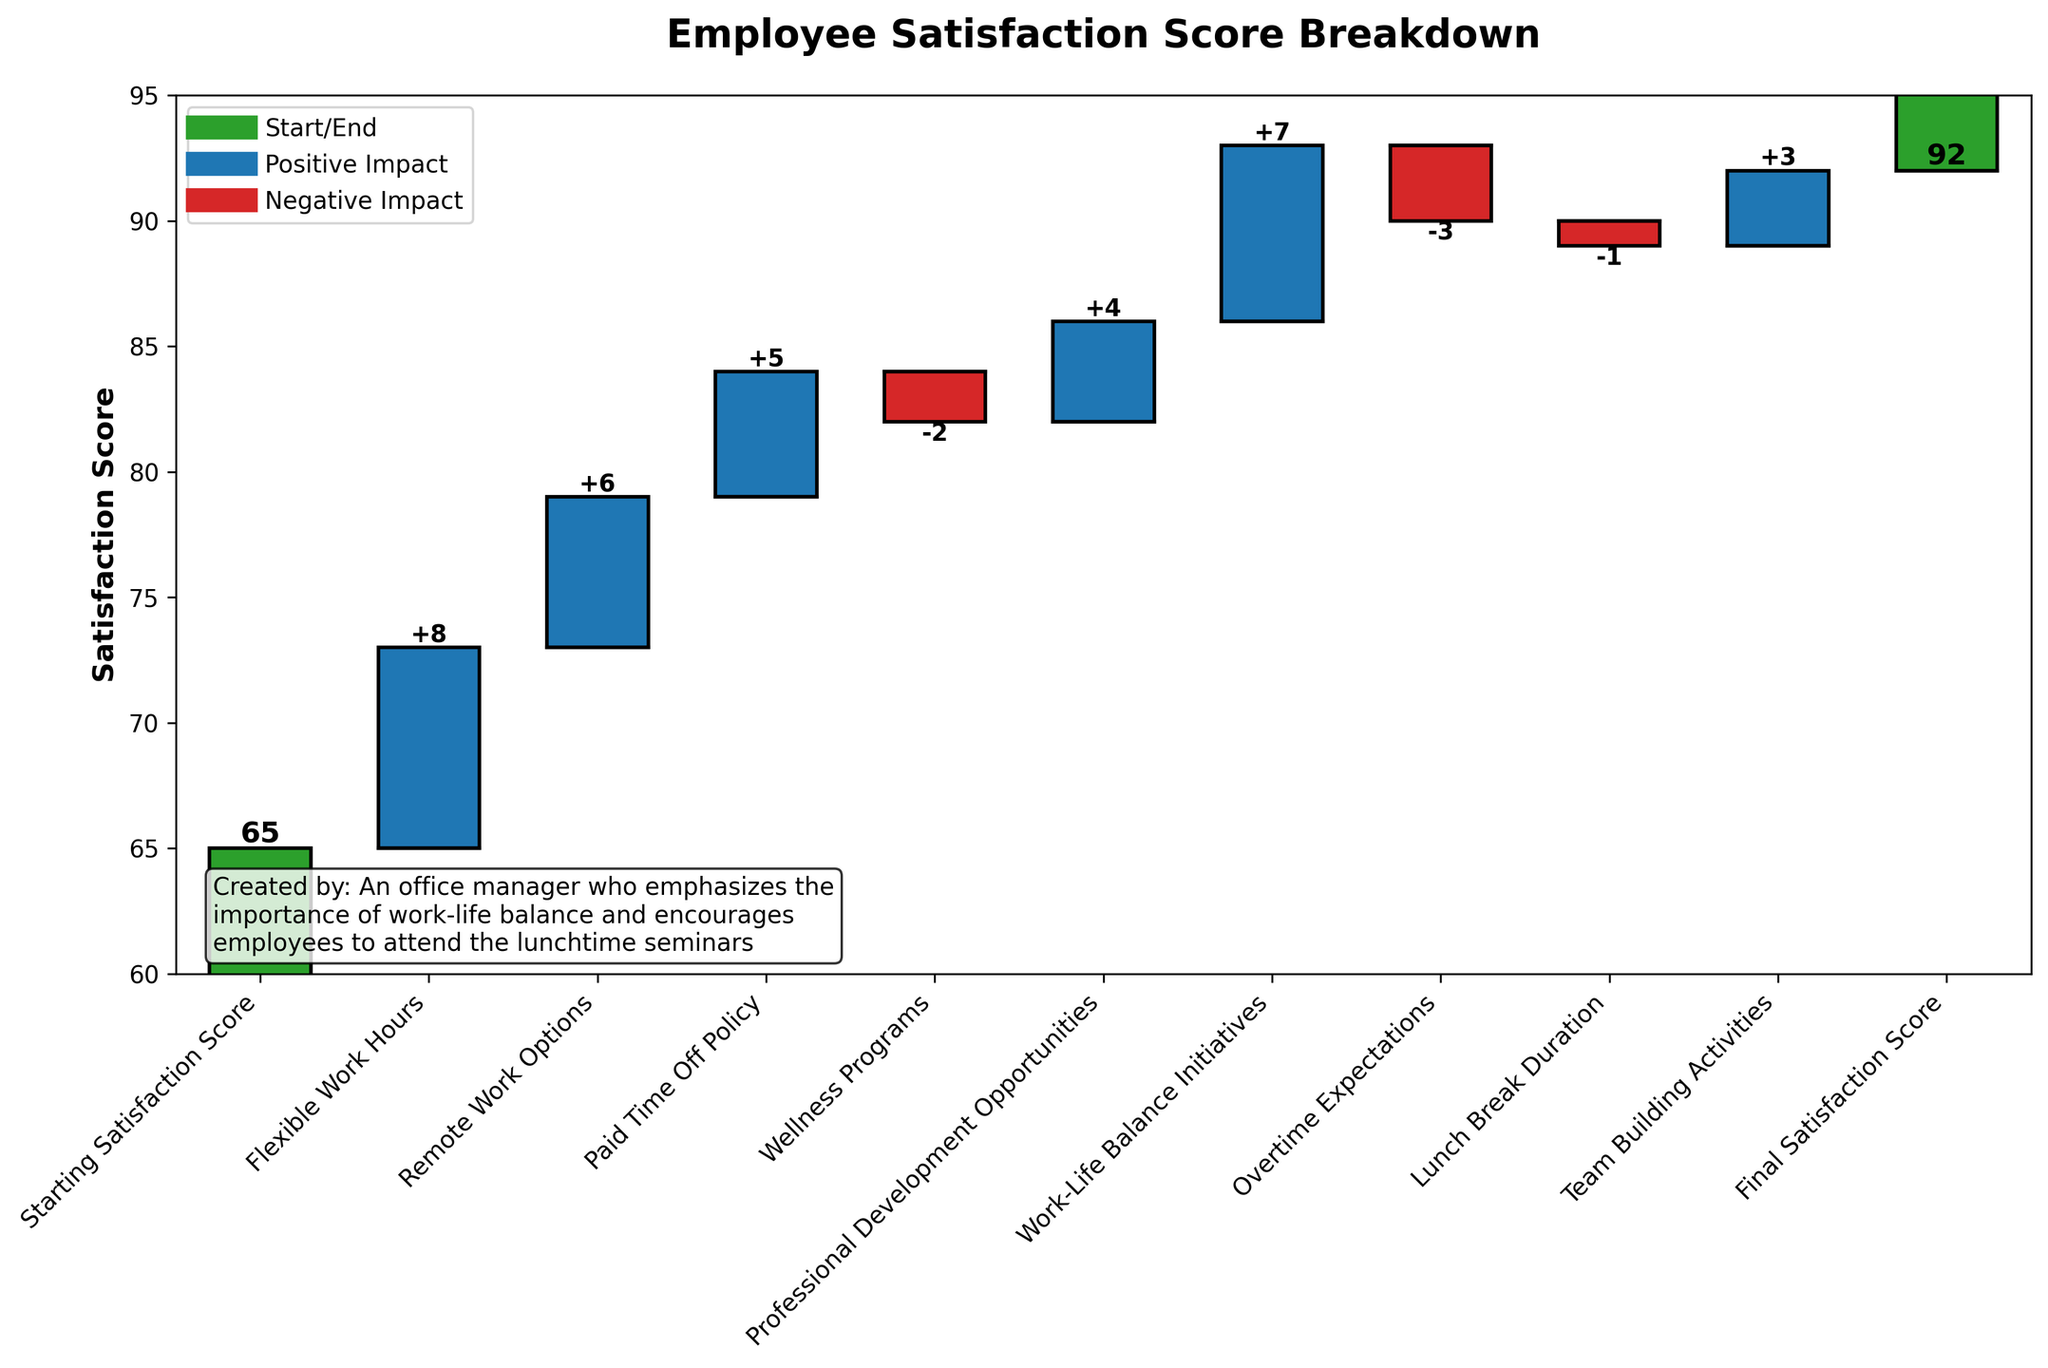What is the title of the figure? The title is usually found at the top of the figure. Here, the title is clearly displayed above the chart, indicating the purpose of the visualization.
Answer: Employee Satisfaction Score Breakdown How many factors contributed positively to the employee satisfaction score? Positive contributions are represented by bars with a positive value and a specific color (e.g., blue). By counting these bars, we find that five factors contributed positively: Flexible Work Hours, Remote Work Options, Paid Time Off Policy, Professional Development Opportunities, and Work-Life Balance Initiatives.
Answer: 5 What is the effect of Wellness Programs on employee satisfaction according to the chart? The chart shows a bar for Wellness Programs with a negative value. The value at the top of this bar is labeled as -2, indicating a decrease in the satisfaction score.
Answer: -2 What is the cumulative effect of Professional Development Opportunities and Work-Life Balance Initiatives? To find the cumulative effect, we sum the values of these two factors. Professional Development Opportunities contribute +4 and Work-Life Balance Initiatives contribute +7. Adding these gives 4 + 7 = 11.
Answer: 11 Which factor had the most negative impact on the employee satisfaction score? The factor with the largest negative value in the chart is Overtime Expectations, with a value of -3.
Answer: Overtime Expectations How does the score change from Starting Satisfaction Score to Final Satisfaction Score? The Starting Satisfaction Score is 65, and the Final Satisfaction Score is 92. The change can be calculated by subtracting the starting score from the final score: 92 - 65 = 27.
Answer: 27 What is the percentage increase in the employee satisfaction score from the Starting Satisfaction Score to the Final Satisfaction Score? To find the percentage increase, we use the formula: ((Final Score - Starting Score) / Starting Score) * 100. This gives: ((92 - 65) / 65) * 100 ≈ 41.54%.
Answer: 41.54% Compare the impact of Flexible Work Hours and Remote Work Options on the satisfaction score. Flexible Work Hours contributed +8, and Remote Work Options contributed +6. Flexible Work Hours had a greater positive impact compared to Remote Work Options by 2 points.
Answer: Flexible Work Hours had a greater positive impact by 2 points What is the score after adding the impact of Flexible Work Hours to the Starting Satisfaction Score? Starting Satisfaction Score is 65. Adding the impact of Flexible Work Hours (+8) results in 65 + 8 = 73.
Answer: 73 